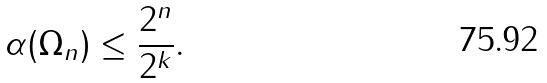<formula> <loc_0><loc_0><loc_500><loc_500>\alpha ( \Omega _ { n } ) \leq \frac { 2 ^ { n } } { 2 ^ { k } } .</formula> 